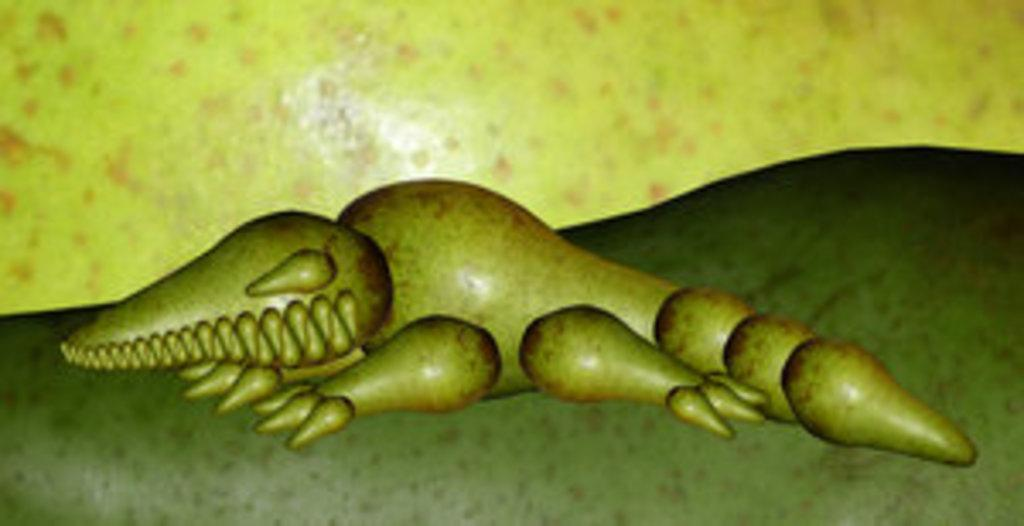What type of animal is depicted in the animated picture in the image? There is an animated picture of a crocodile in the image. What type of cake is being served at the birthday party in the image? There is no birthday party or cake present in the image; it only features an animated picture of a crocodile. 